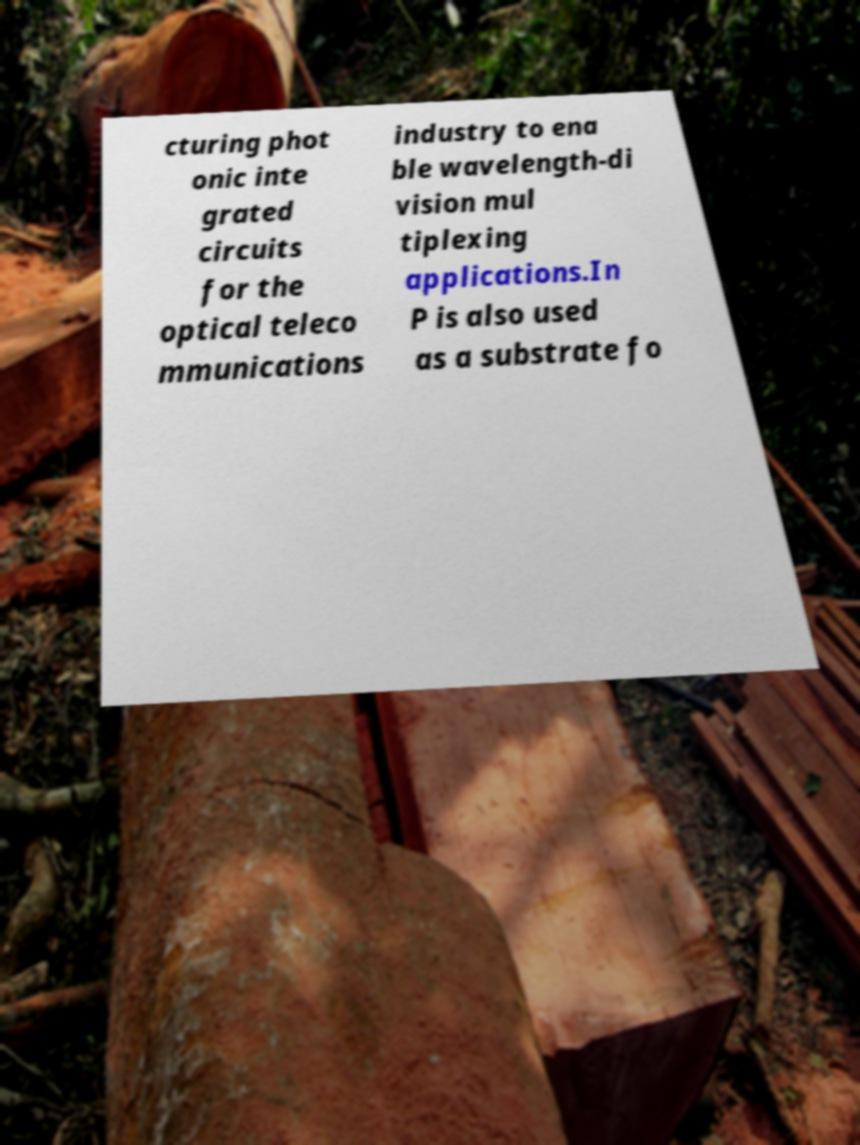Can you accurately transcribe the text from the provided image for me? cturing phot onic inte grated circuits for the optical teleco mmunications industry to ena ble wavelength-di vision mul tiplexing applications.In P is also used as a substrate fo 